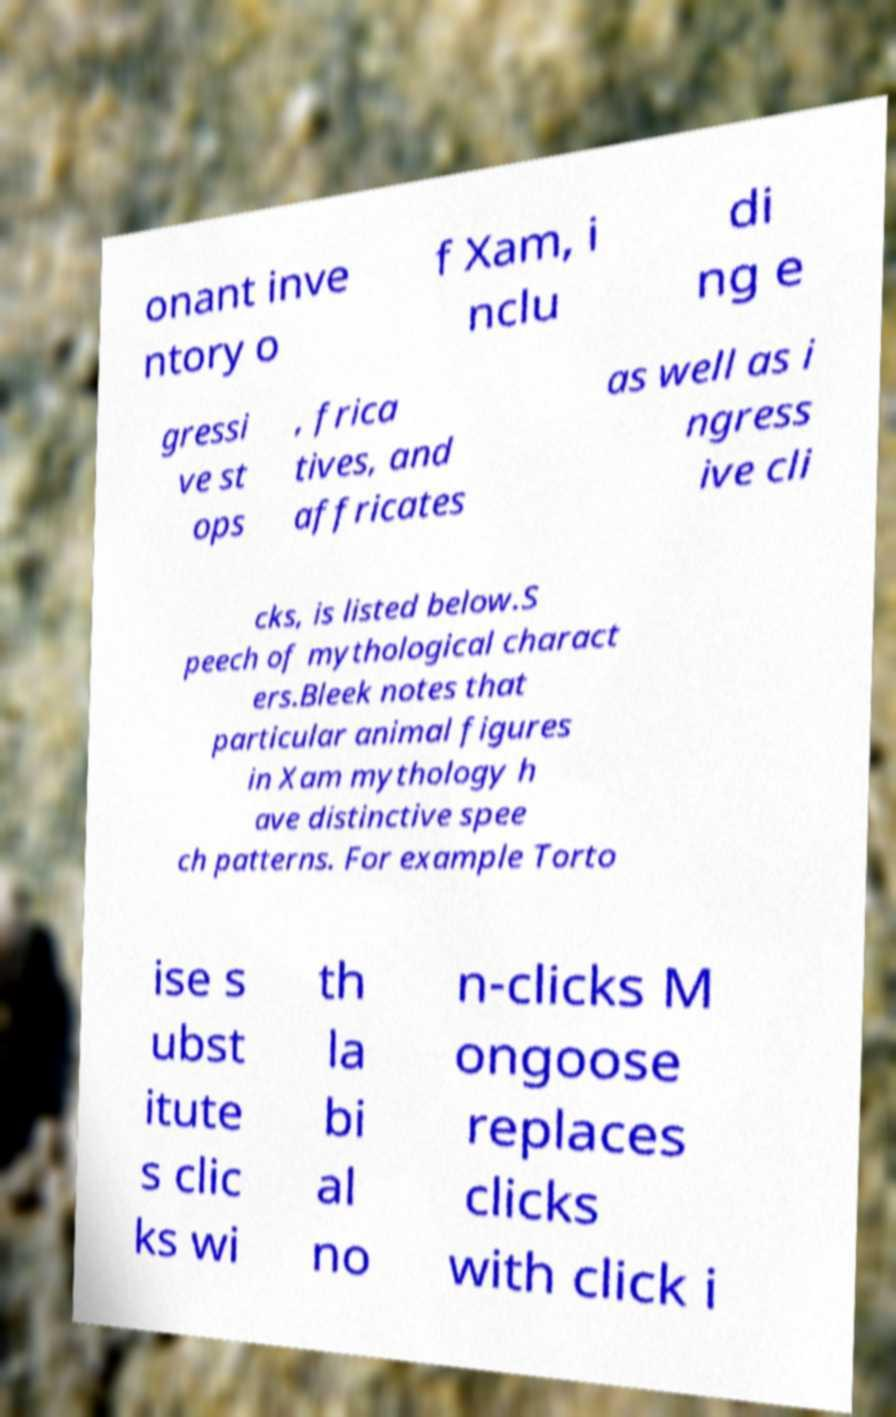Can you read and provide the text displayed in the image?This photo seems to have some interesting text. Can you extract and type it out for me? onant inve ntory o f Xam, i nclu di ng e gressi ve st ops , frica tives, and affricates as well as i ngress ive cli cks, is listed below.S peech of mythological charact ers.Bleek notes that particular animal figures in Xam mythology h ave distinctive spee ch patterns. For example Torto ise s ubst itute s clic ks wi th la bi al no n-clicks M ongoose replaces clicks with click i 